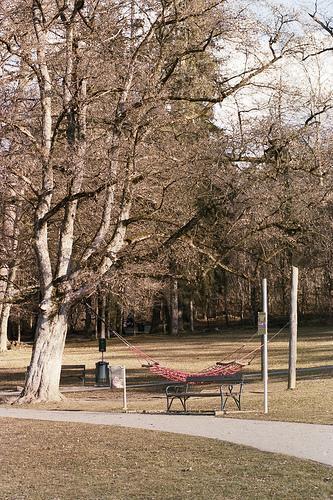How many park benches?
Give a very brief answer. 2. How many tall poles?
Give a very brief answer. 2. How many trashcans?
Give a very brief answer. 2. 